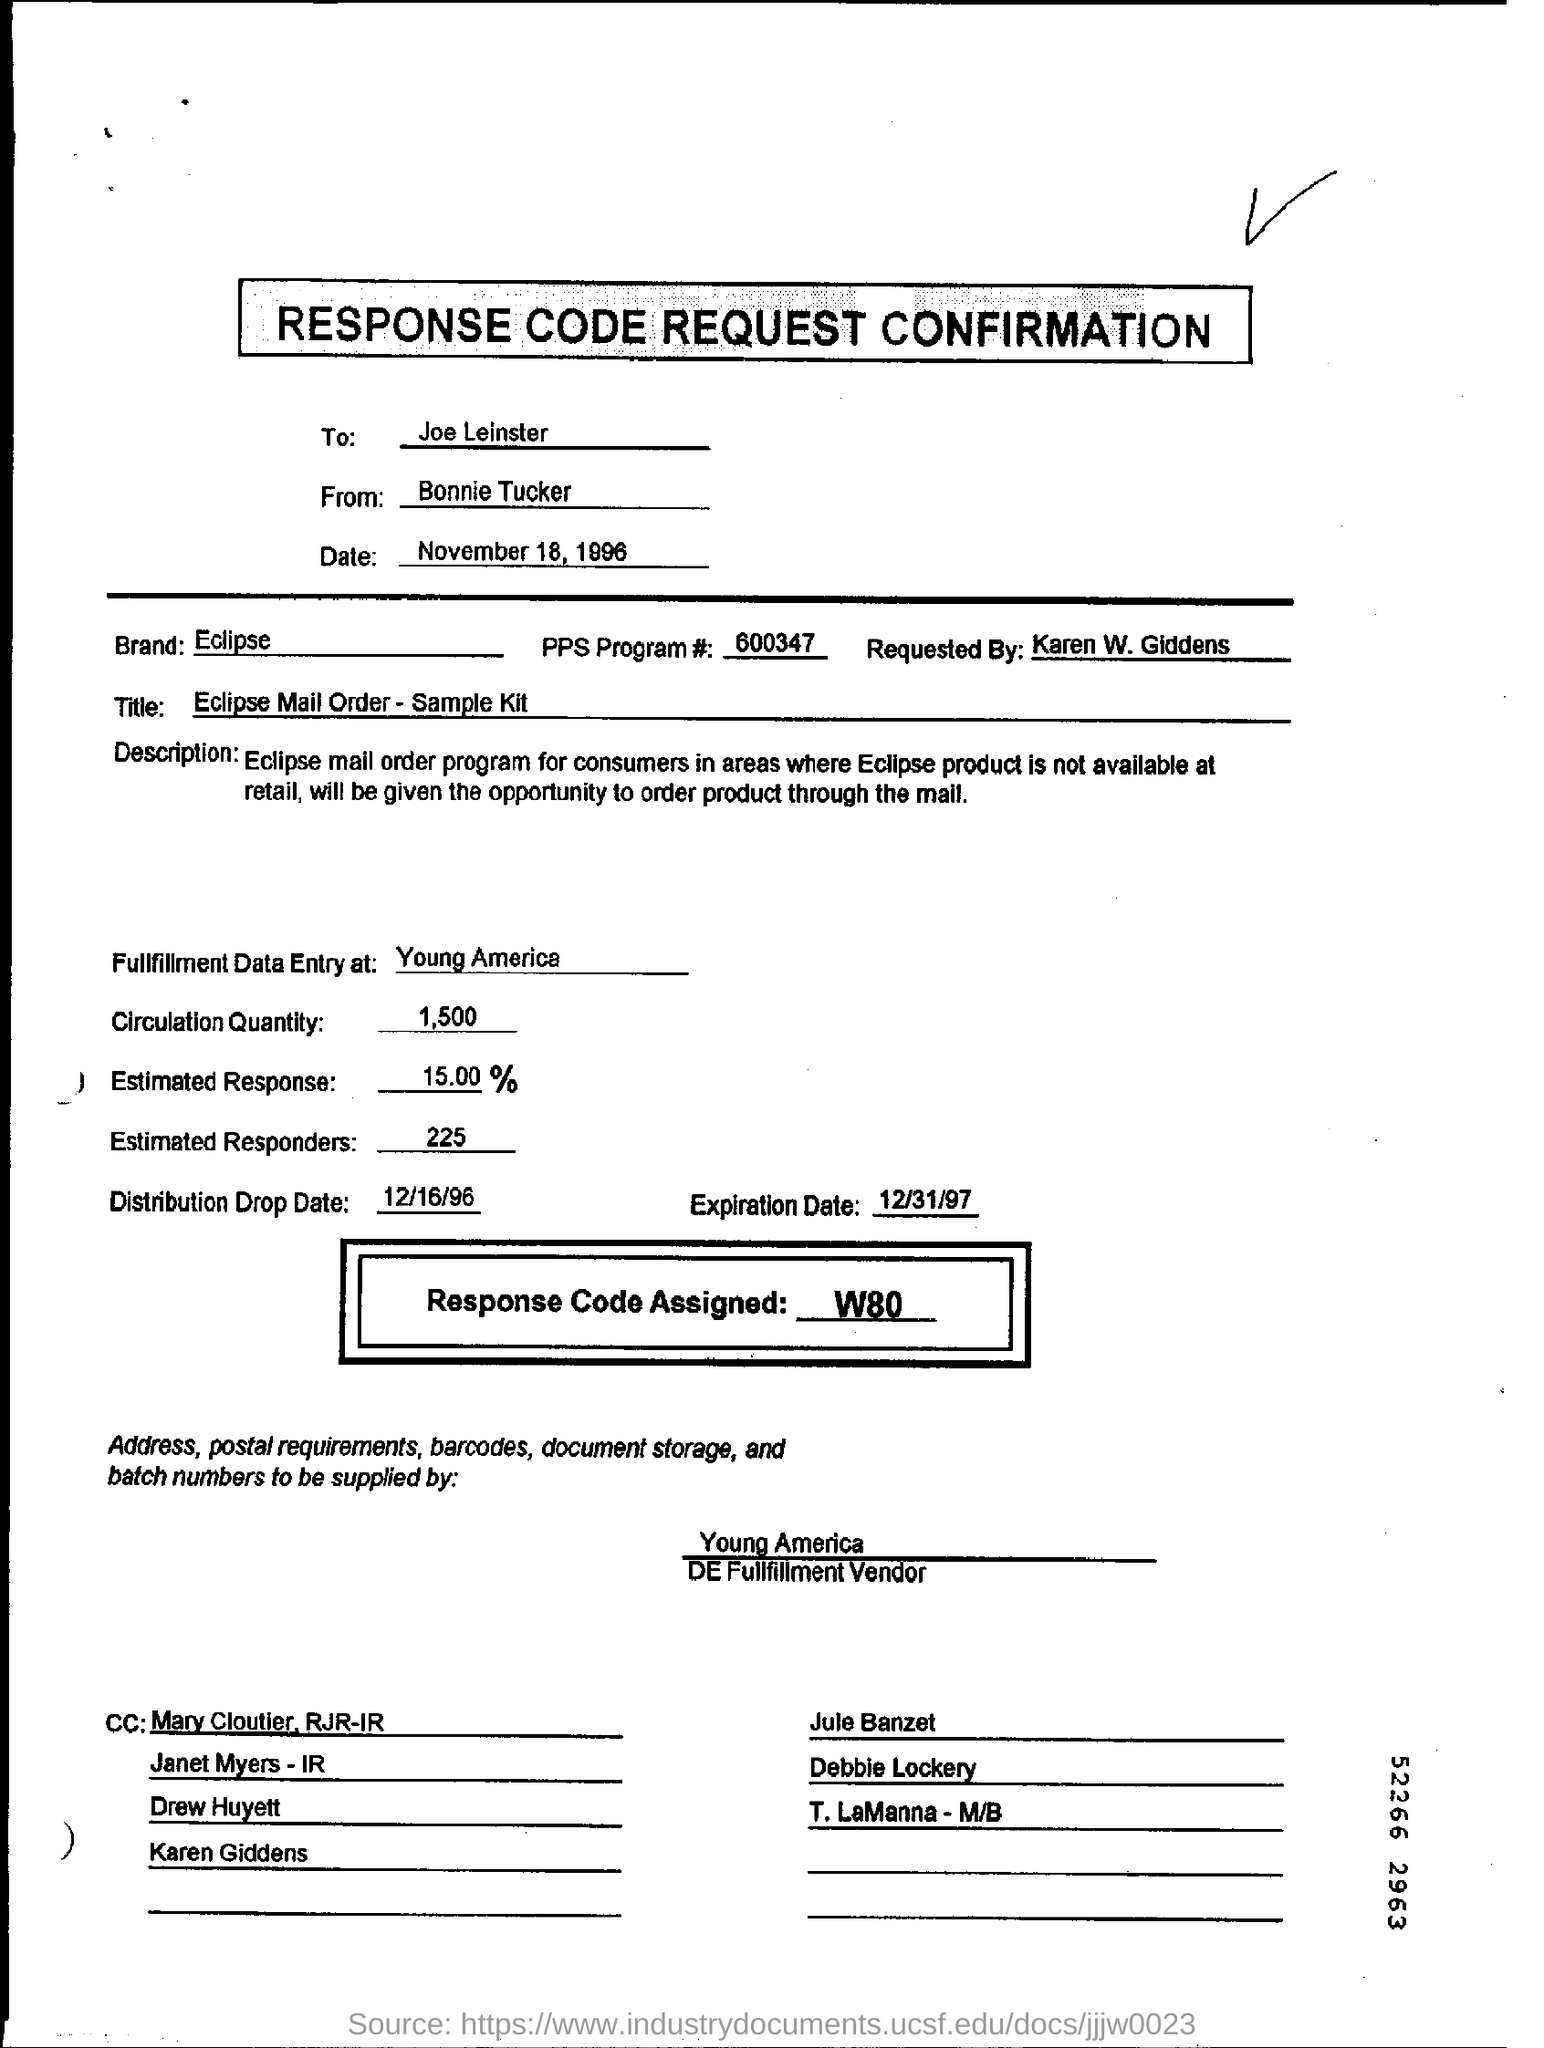To whom is this document addressed?
Your response must be concise. Joe Leinster. What is the date mentioned in the form?
Offer a terse response. November 18, 1996. What is the Estimated Response mentioned?
Your answer should be compact. 15.00%. 